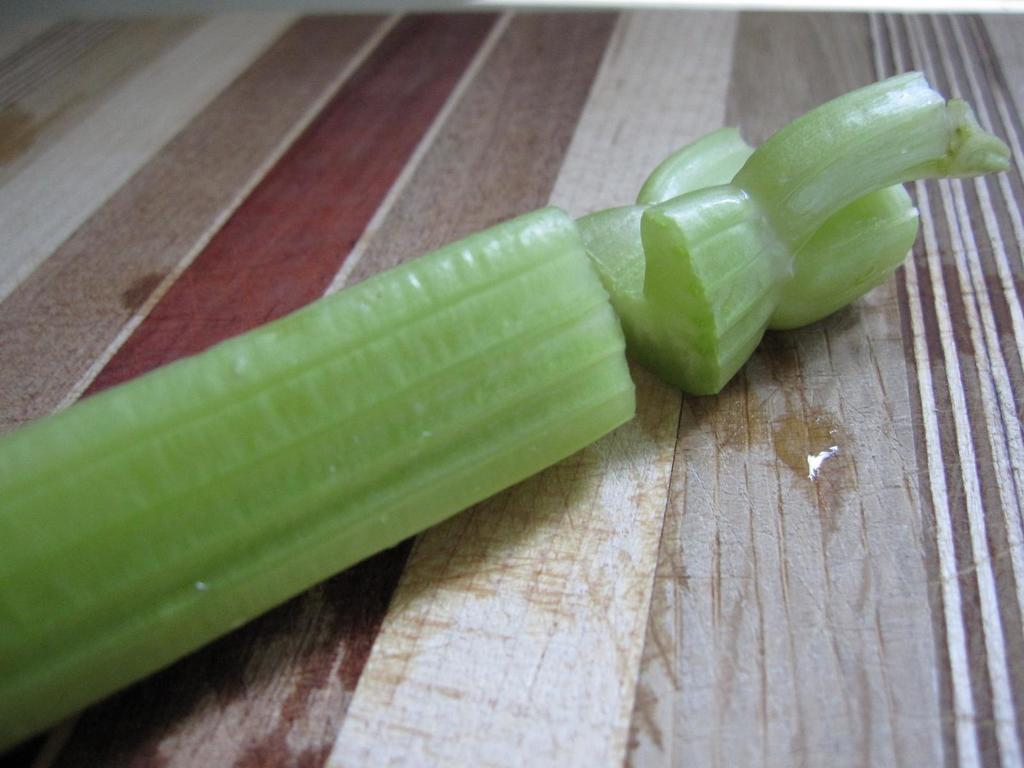What type of food is present in the image? There is a vegetable in the image. How is the vegetable prepared? The vegetable is sliced. Where is the sliced vegetable located? The sliced vegetable is placed on a table. What type of mist can be seen surrounding the vegetable in the image? There is no mist present in the image; it only features a sliced vegetable on a table. 